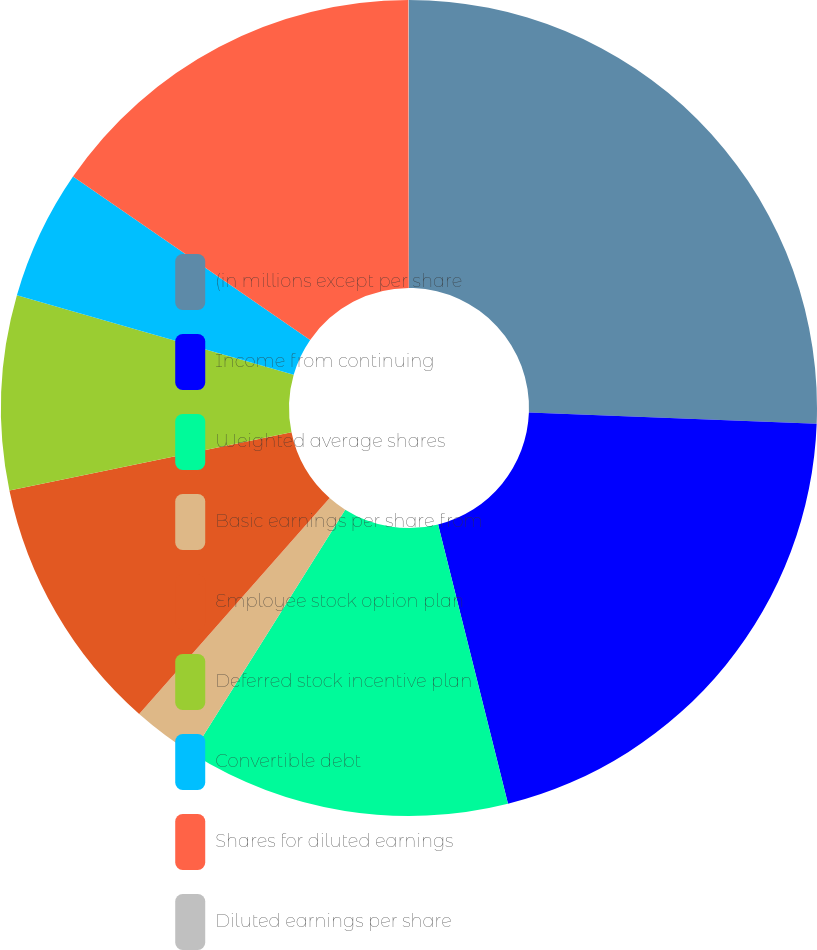Convert chart. <chart><loc_0><loc_0><loc_500><loc_500><pie_chart><fcel>(in millions except per share<fcel>Income from continuing<fcel>Weighted average shares<fcel>Basic earnings per share from<fcel>Employee stock option plan<fcel>Deferred stock incentive plan<fcel>Convertible debt<fcel>Shares for diluted earnings<fcel>Diluted earnings per share<nl><fcel>25.61%<fcel>20.49%<fcel>12.82%<fcel>2.58%<fcel>10.26%<fcel>7.7%<fcel>5.14%<fcel>15.38%<fcel>0.02%<nl></chart> 